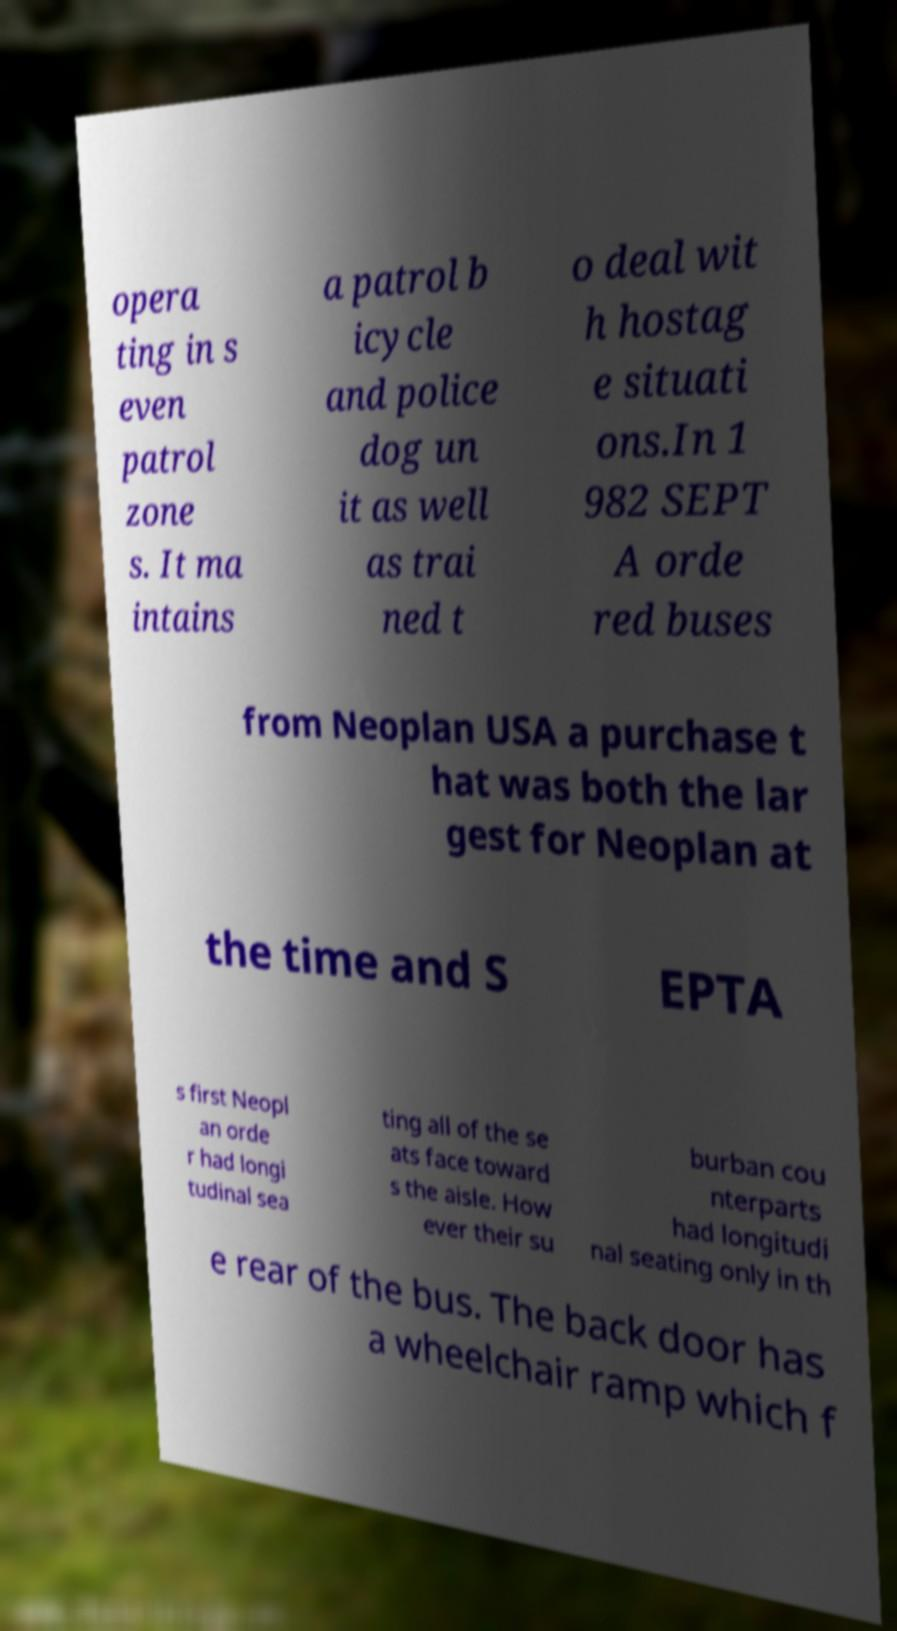For documentation purposes, I need the text within this image transcribed. Could you provide that? opera ting in s even patrol zone s. It ma intains a patrol b icycle and police dog un it as well as trai ned t o deal wit h hostag e situati ons.In 1 982 SEPT A orde red buses from Neoplan USA a purchase t hat was both the lar gest for Neoplan at the time and S EPTA s first Neopl an orde r had longi tudinal sea ting all of the se ats face toward s the aisle. How ever their su burban cou nterparts had longitudi nal seating only in th e rear of the bus. The back door has a wheelchair ramp which f 